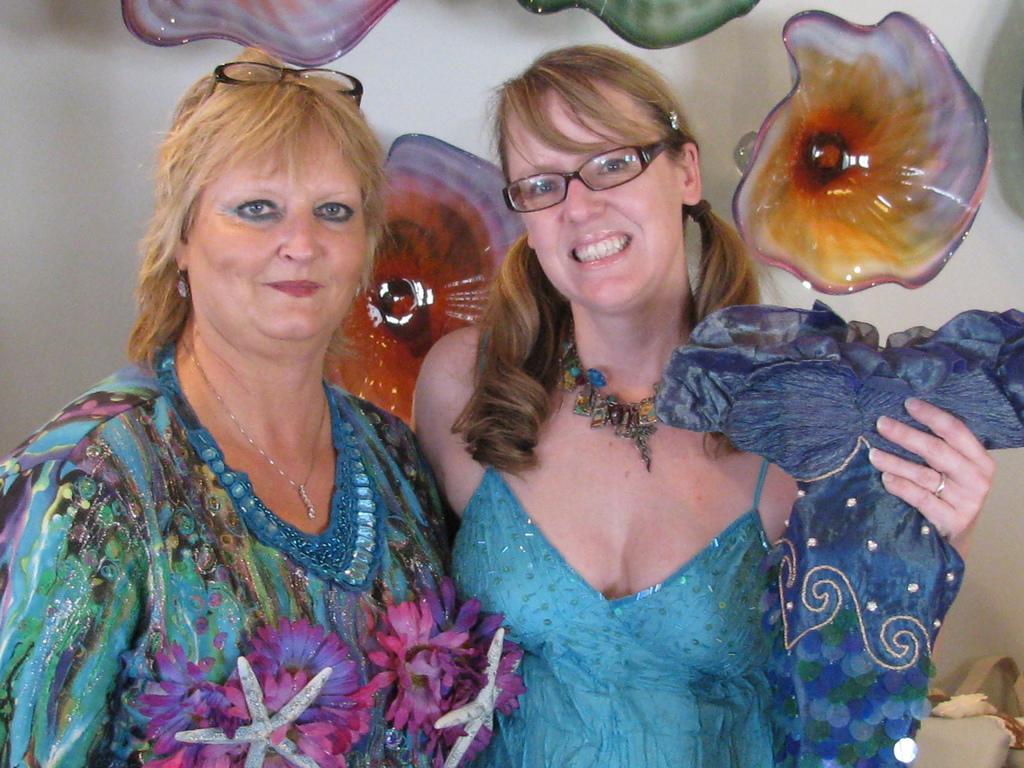How would you summarize this image in a sentence or two? In the picture we can see two women are standing together and they are smiling and one woman is holding some blue color cloth and behind them we can see a wall with some flower sculptures near it. 